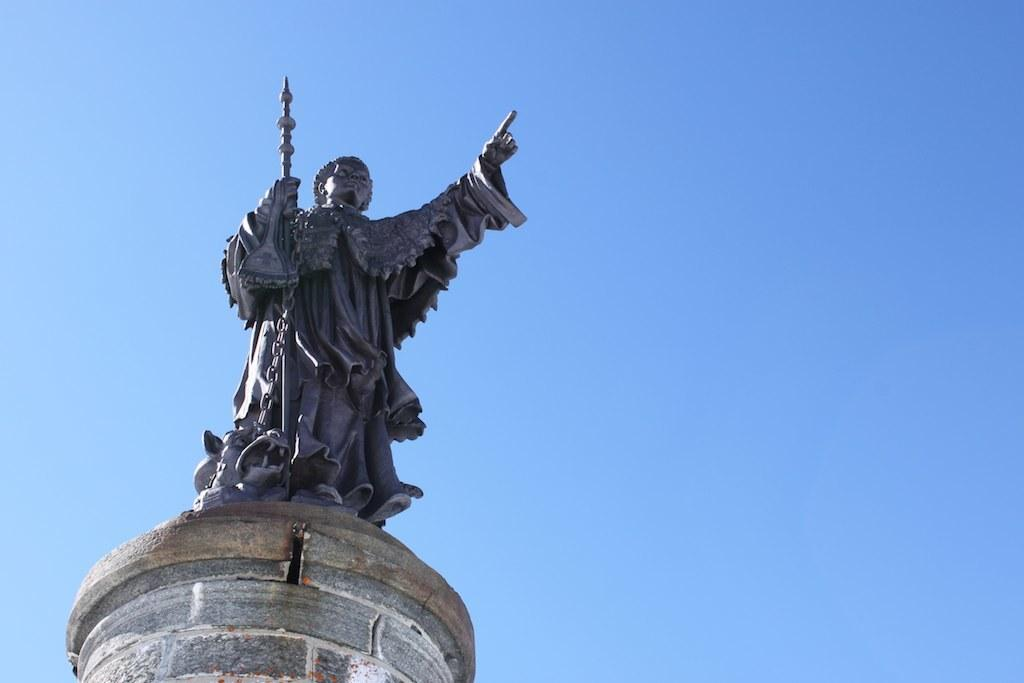What is the main subject of the picture? The main subject of the picture is a statue. What is the statue holding in the image? The statue is holding an object. What can be seen in the background of the image? The sky is clear in the background of the image. What type of thought can be seen on the statue's face in the image? There is no indication of a thought on the statue's face in the image, as it is a statue and not a living being capable of expressing thoughts. 